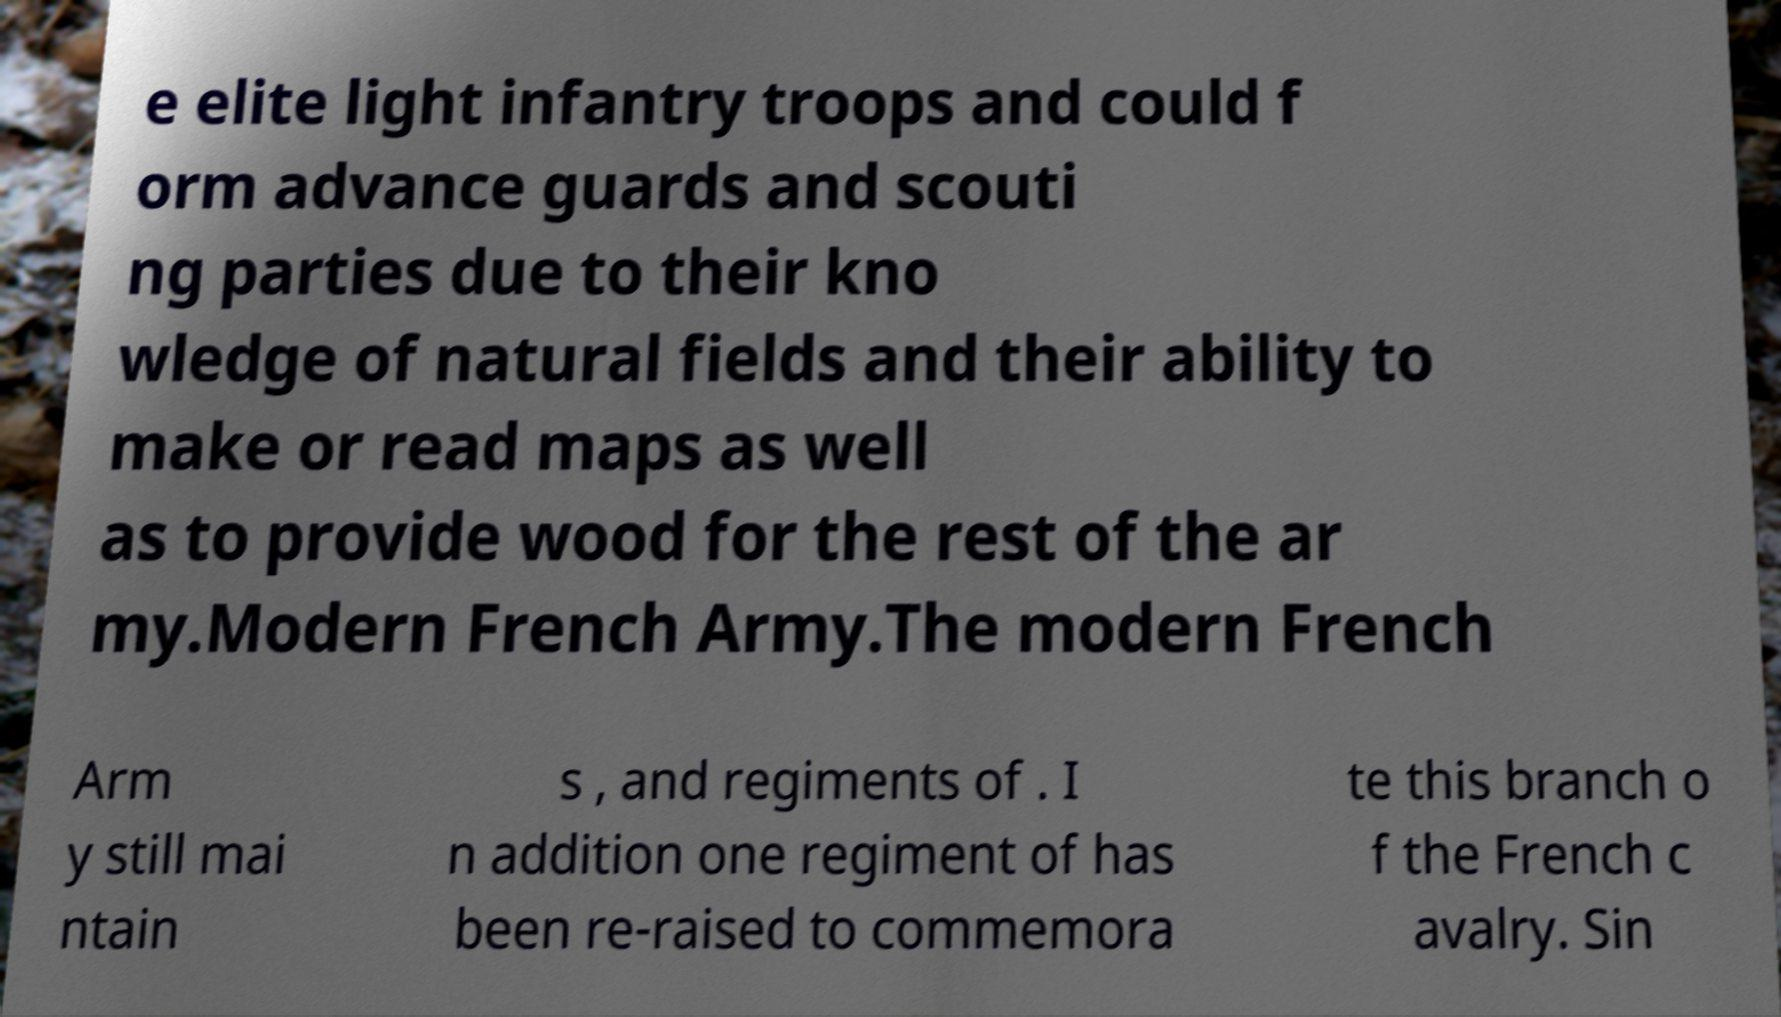Could you assist in decoding the text presented in this image and type it out clearly? e elite light infantry troops and could f orm advance guards and scouti ng parties due to their kno wledge of natural fields and their ability to make or read maps as well as to provide wood for the rest of the ar my.Modern French Army.The modern French Arm y still mai ntain s , and regiments of . I n addition one regiment of has been re-raised to commemora te this branch o f the French c avalry. Sin 